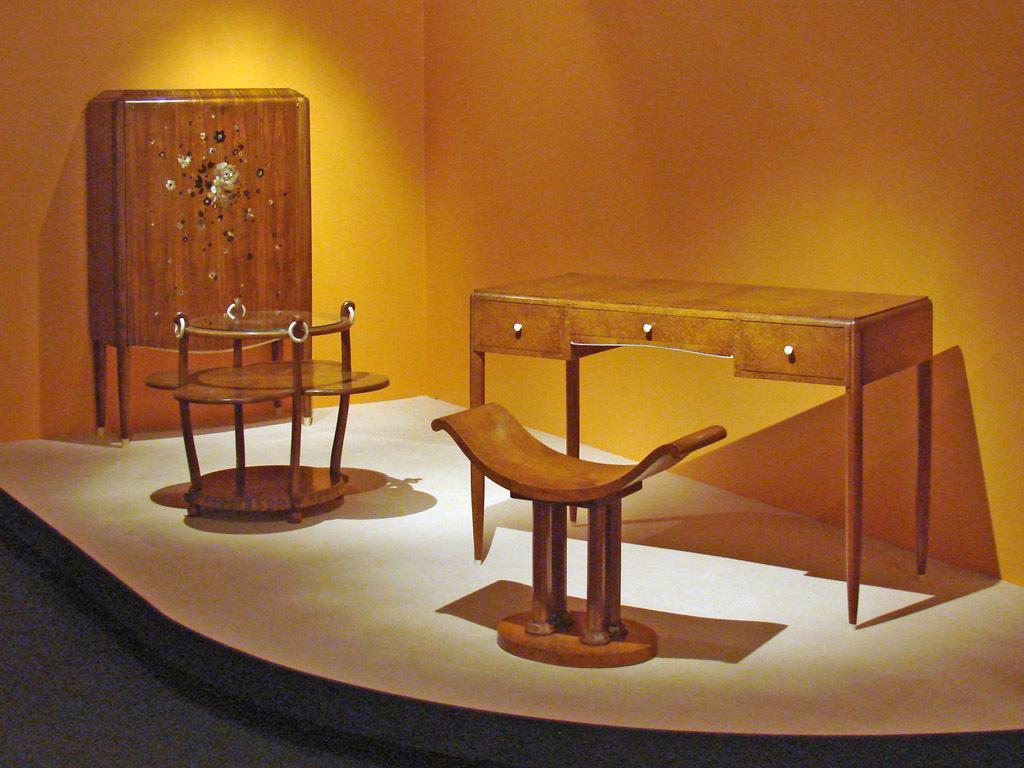Could you give a brief overview of what you see in this image? In this image there is a table. Before it there is a stool on the floor. Left side there is a table. Behind there is a wooden furniture. Background there is a wall. 